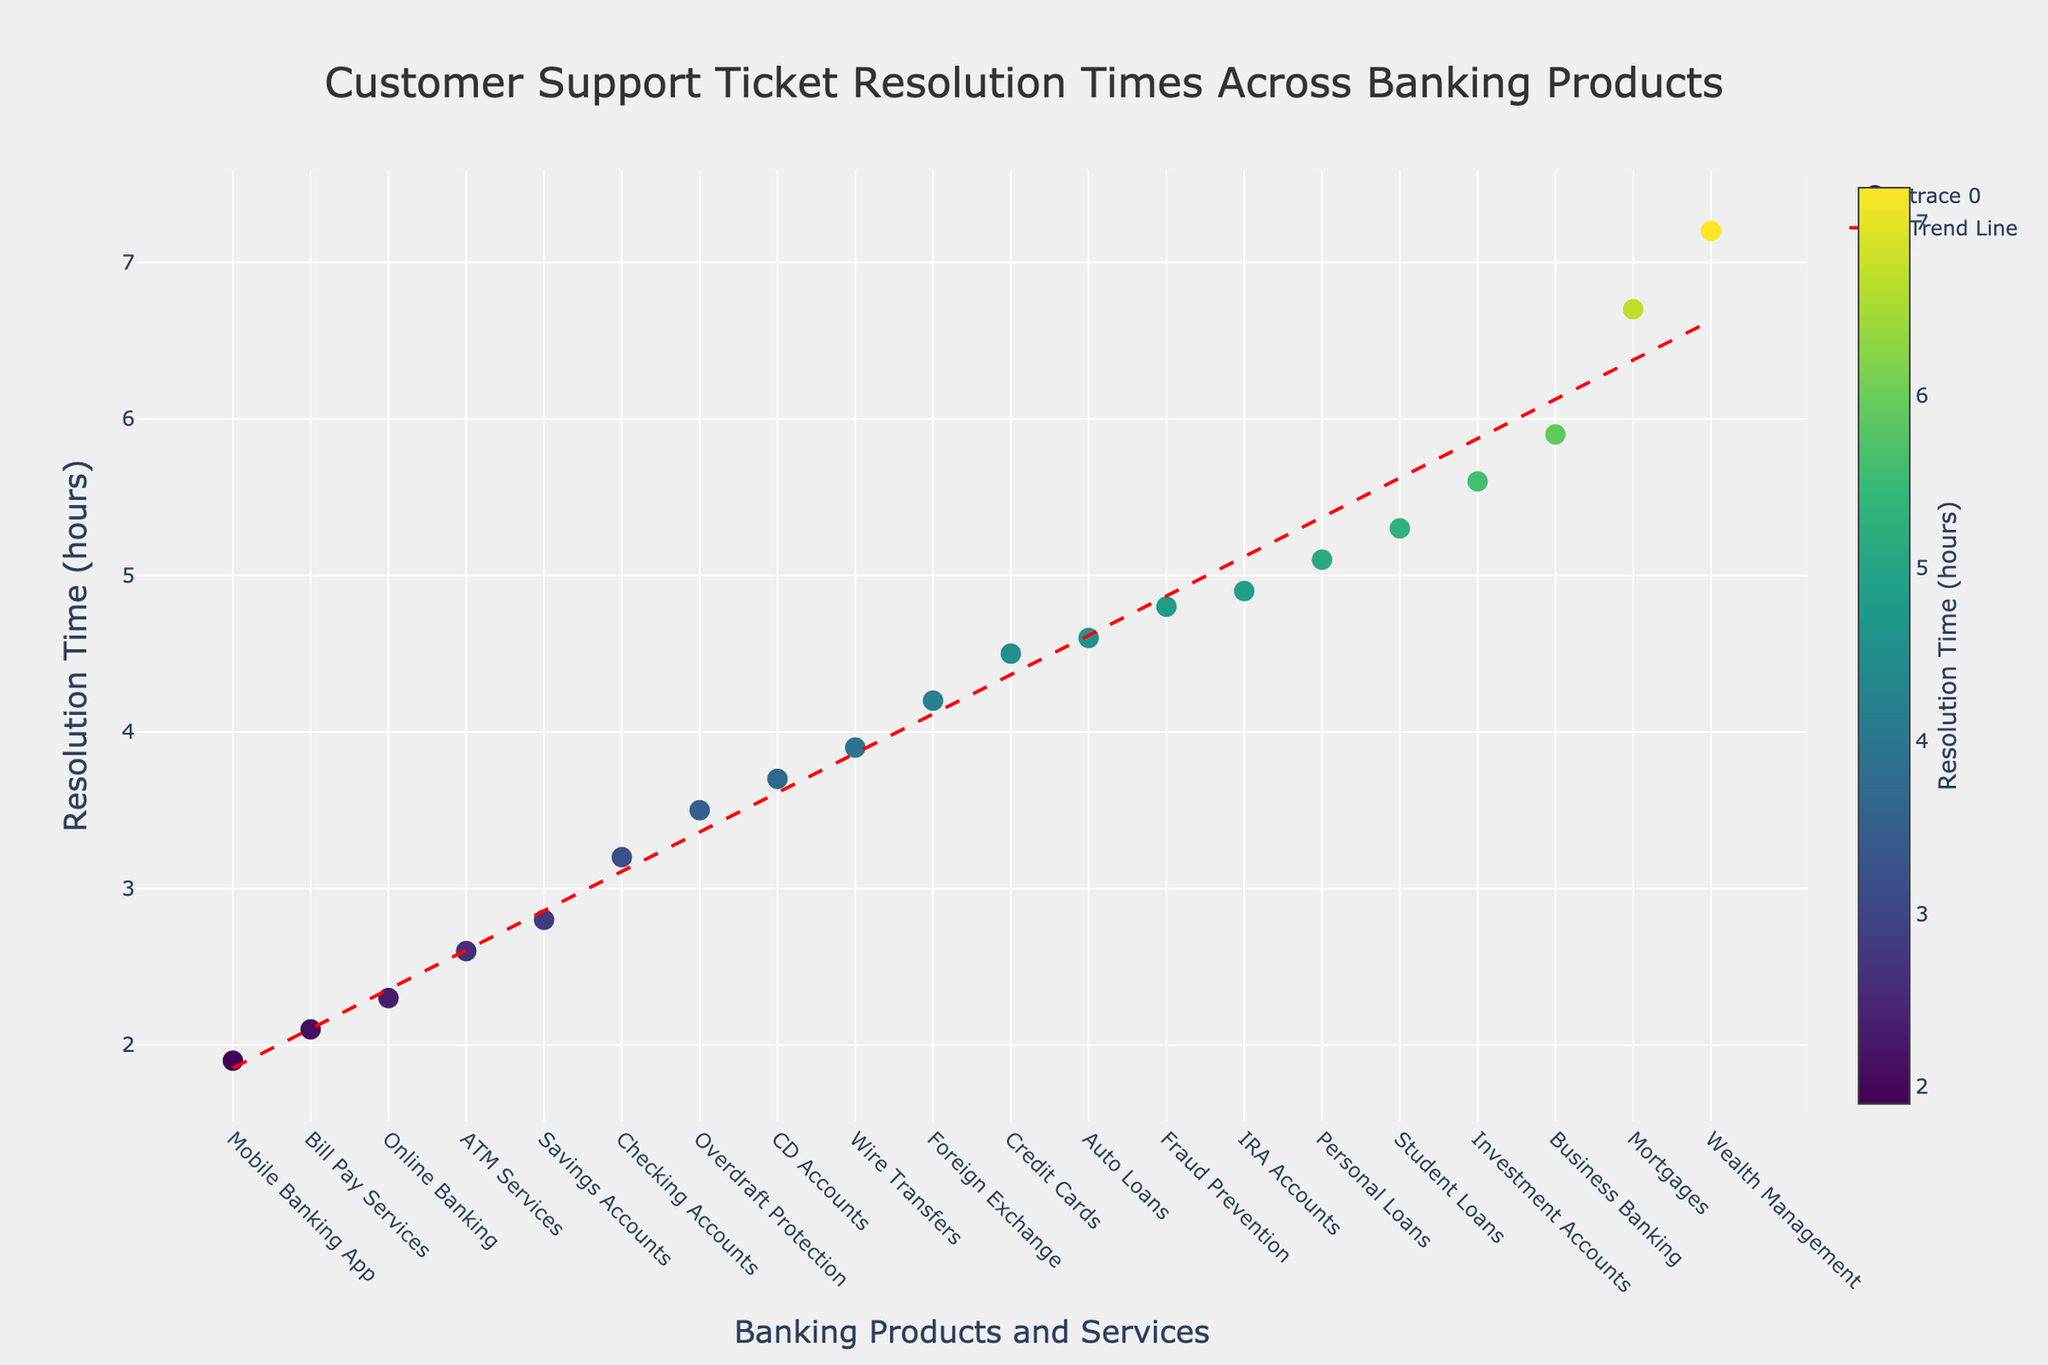What's the title of the plot? Look at the top center of the figure; the title is usually prominently displayed there.
Answer: Customer Support Ticket Resolution Times Across Banking Products Which banking product has the fastest average resolution time? Locate the data point on the x-axis that corresponds to the lowest position on the y-axis; this product has the shortest resolution time.
Answer: Mobile Banking App Which banking product has the slowest average resolution time? Find the data point on the x-axis that corresponds to the highest position on the y-axis; this product has the longest resolution time.
Answer: Wealth Management What is the resolution time for Checking Accounts? Identify "Checking Accounts" on the x-axis and read its corresponding y-axis value.
Answer: 3.2 hours How many products have a resolution time less than 3 hours? Count the number of data points on the plot that fall below the 3-hour mark on the y-axis.
Answer: 4 What is the average resolution time for Auto Loans and Mortgages? Find the y-axis values for "Auto Loans" and "Mortgages," sum them up, and divide by 2: (4.6 + 6.7) / 2.
Answer: 5.65 hours Which product has a higher resolution time: Business Banking or Investment Accounts? Compare the y-axis values of "Business Banking" and "Investment Accounts"; the one higher up the y-axis has a higher resolution time.
Answer: Investment Accounts What does the trend line in the plot indicate? The red dashed trend line shows the overall trend of resolution times among the products; observe if it is increasing or decreasing.
Answer: Increasing trend Are there more products with resolution times above 5 hours or below 3 hours? Count the number of data points above the 5-hour mark and below the 3-hour mark on the y-axis, then compare these counts.
Answer: Above 5 hours 